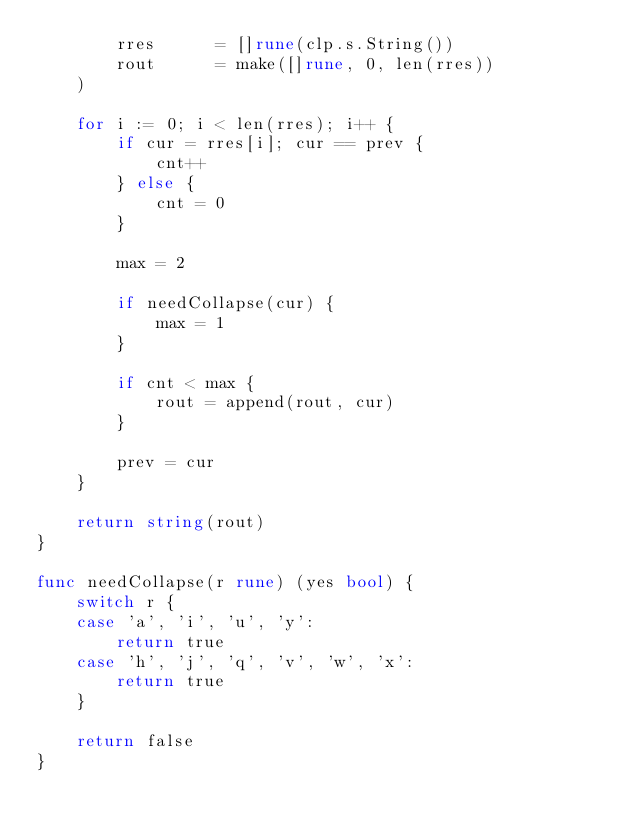<code> <loc_0><loc_0><loc_500><loc_500><_Go_>		rres      = []rune(clp.s.String())
		rout      = make([]rune, 0, len(rres))
	)

	for i := 0; i < len(rres); i++ {
		if cur = rres[i]; cur == prev {
			cnt++
		} else {
			cnt = 0
		}

		max = 2

		if needCollapse(cur) {
			max = 1
		}

		if cnt < max {
			rout = append(rout, cur)
		}

		prev = cur
	}

	return string(rout)
}

func needCollapse(r rune) (yes bool) {
	switch r {
	case 'a', 'i', 'u', 'y':
		return true
	case 'h', 'j', 'q', 'v', 'w', 'x':
		return true
	}

	return false
}
</code> 